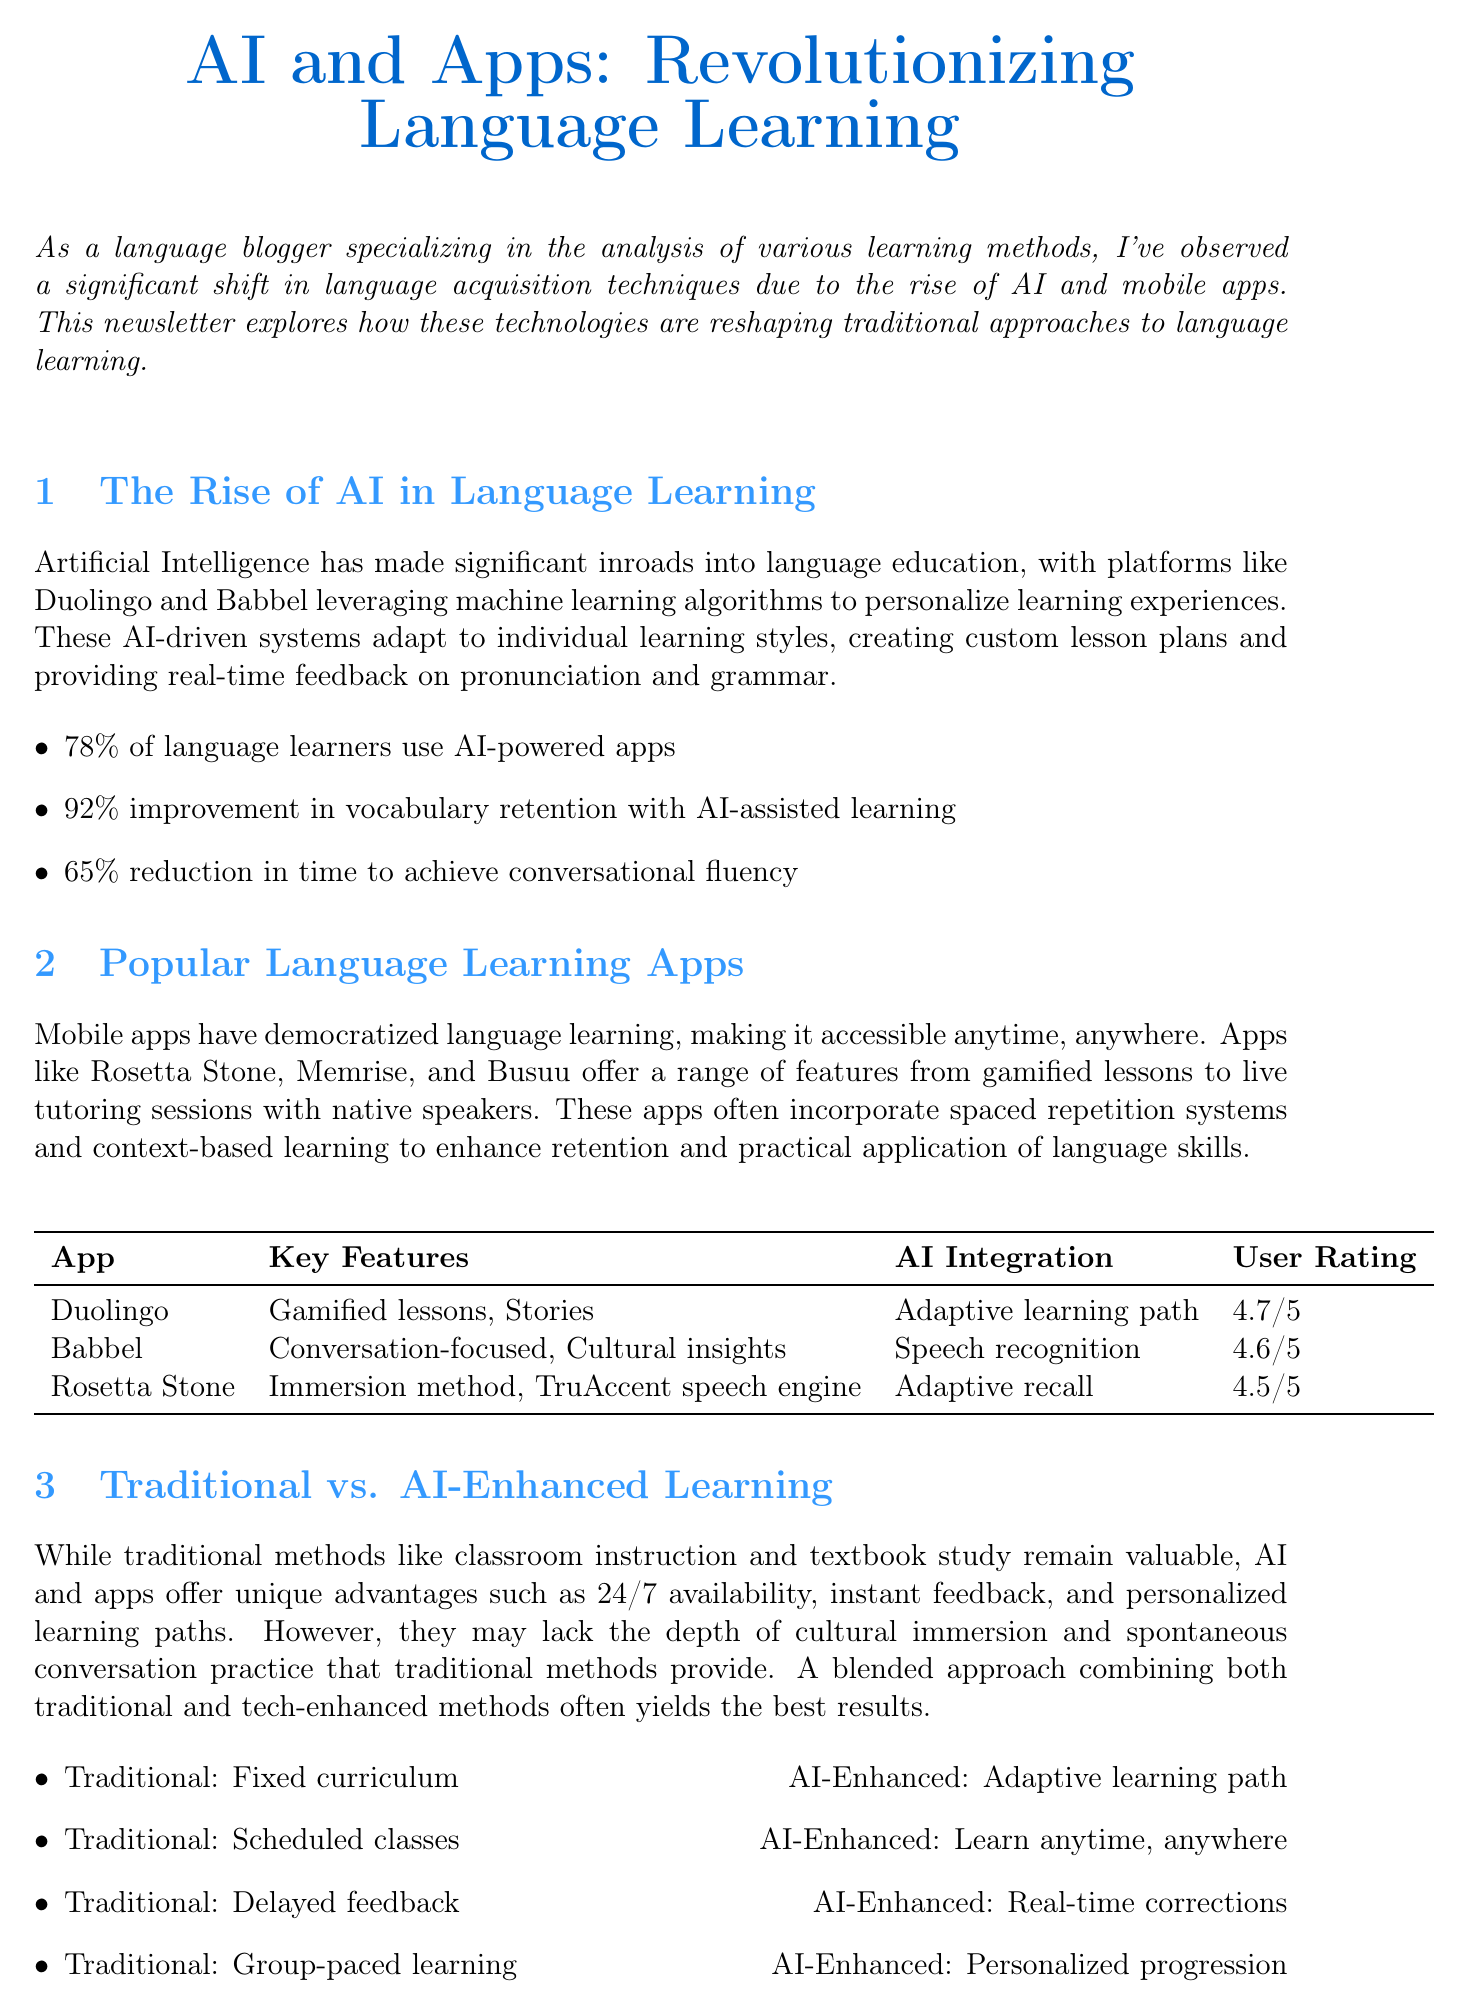What is the title of the newsletter? The title of the newsletter is explicitly stated at the beginning of the document.
Answer: AI and Apps: Revolutionizing Language Learning What percentage of language learners use AI-powered apps? The document includes a statistic highlighting the prevalence of AI-powered apps among language learners.
Answer: 78% Which app has the highest user rating? The user ratings for various language learning apps are compared in a table format, allowing for straightforward identification of the highest-rated app.
Answer: Duolingo What key feature does Babbel offer? The document specifies various key features for each app, including those offered by Babbel.
Answer: Conversation-focused, Cultural insights What kind of learning path do AI-enhanced methods provide? The differences between traditional and AI-enhanced language learning are contrasted in the document.
Answer: Adaptive learning path How long did Sarah Chen take to learn Mandarin? A user testimonial provides specific details about the time frame of learning Mandarin using an app.
Answer: 6 months What unique advantage do AI-based language apps provide compared to traditional methods? The document lists advantages of AI-based apps, focusing on their 24/7 availability.
Answer: Instant feedback Who expressed skepticism about AI in language learning? The testimonials feature opinions from users, including their feelings before trying AI technologies.
Answer: Amelia Thompson 